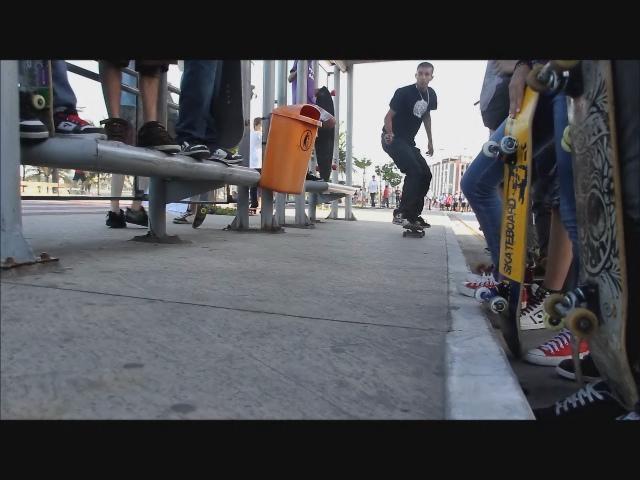What is the orange object used for?
Indicate the correct choice and explain in the format: 'Answer: answer
Rationale: rationale.'
Options: Storage, scoring, trash, blocking. Answer: trash.
Rationale: It's used for a trash can. 